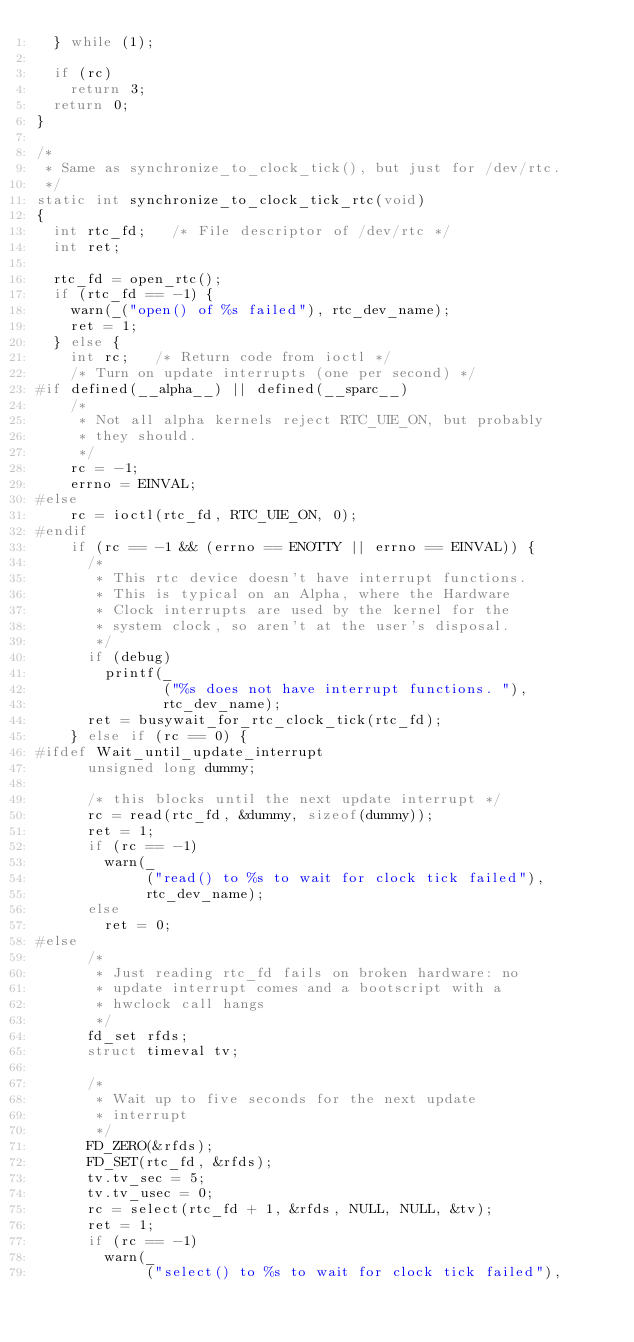Convert code to text. <code><loc_0><loc_0><loc_500><loc_500><_C_>	} while (1);

	if (rc)
		return 3;
	return 0;
}

/*
 * Same as synchronize_to_clock_tick(), but just for /dev/rtc.
 */
static int synchronize_to_clock_tick_rtc(void)
{
	int rtc_fd;		/* File descriptor of /dev/rtc */
	int ret;

	rtc_fd = open_rtc();
	if (rtc_fd == -1) {
		warn(_("open() of %s failed"), rtc_dev_name);
		ret = 1;
	} else {
		int rc;		/* Return code from ioctl */
		/* Turn on update interrupts (one per second) */
#if defined(__alpha__) || defined(__sparc__)
		/*
		 * Not all alpha kernels reject RTC_UIE_ON, but probably
		 * they should.
		 */
		rc = -1;
		errno = EINVAL;
#else
		rc = ioctl(rtc_fd, RTC_UIE_ON, 0);
#endif
		if (rc == -1 && (errno == ENOTTY || errno == EINVAL)) {
			/*
			 * This rtc device doesn't have interrupt functions.
			 * This is typical on an Alpha, where the Hardware
			 * Clock interrupts are used by the kernel for the
			 * system clock, so aren't at the user's disposal.
			 */
			if (debug)
				printf(_
				       ("%s does not have interrupt functions. "),
				       rtc_dev_name);
			ret = busywait_for_rtc_clock_tick(rtc_fd);
		} else if (rc == 0) {
#ifdef Wait_until_update_interrupt
			unsigned long dummy;

			/* this blocks until the next update interrupt */
			rc = read(rtc_fd, &dummy, sizeof(dummy));
			ret = 1;
			if (rc == -1)
				warn(_
				     ("read() to %s to wait for clock tick failed"),
				     rtc_dev_name);
			else
				ret = 0;
#else
			/*
			 * Just reading rtc_fd fails on broken hardware: no
			 * update interrupt comes and a bootscript with a
			 * hwclock call hangs
			 */
			fd_set rfds;
			struct timeval tv;

			/*
			 * Wait up to five seconds for the next update
			 * interrupt
			 */
			FD_ZERO(&rfds);
			FD_SET(rtc_fd, &rfds);
			tv.tv_sec = 5;
			tv.tv_usec = 0;
			rc = select(rtc_fd + 1, &rfds, NULL, NULL, &tv);
			ret = 1;
			if (rc == -1)
				warn(_
				     ("select() to %s to wait for clock tick failed"),</code> 